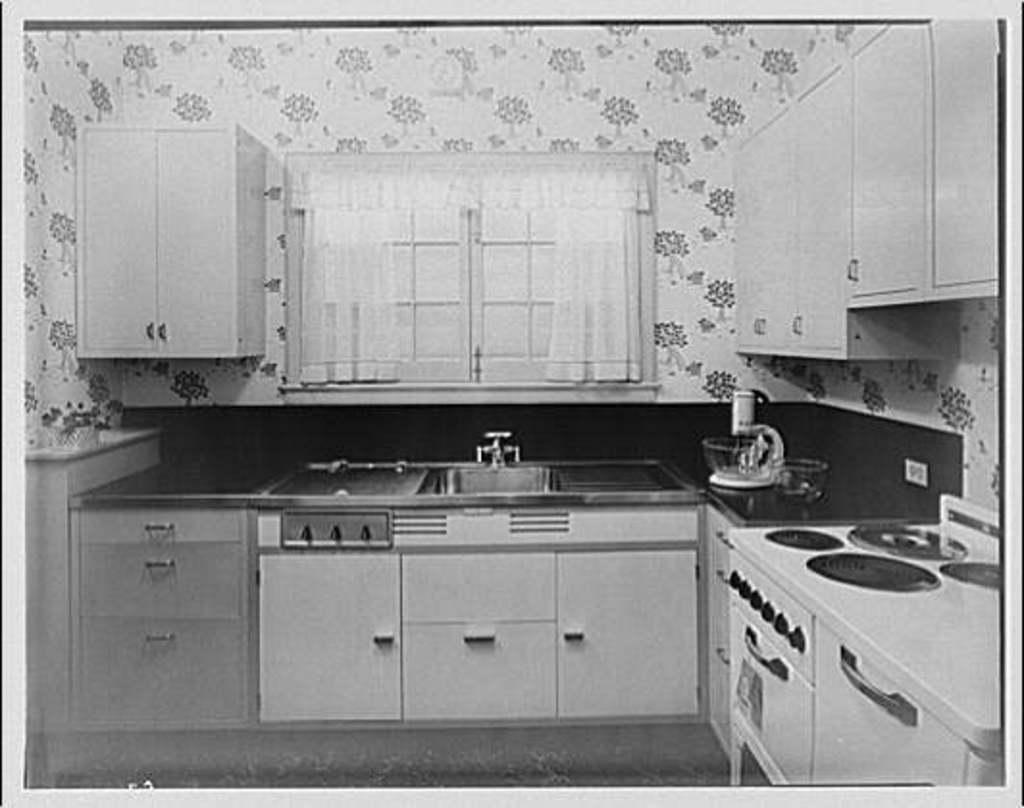Could you give a brief overview of what you see in this image? In this image we can see the inside view of the room and there are cupboards with racks. There is the sink and a white color object. We can see there is the socket attached to the wall. And there are cupboards attached to the wall and there are curtains. 